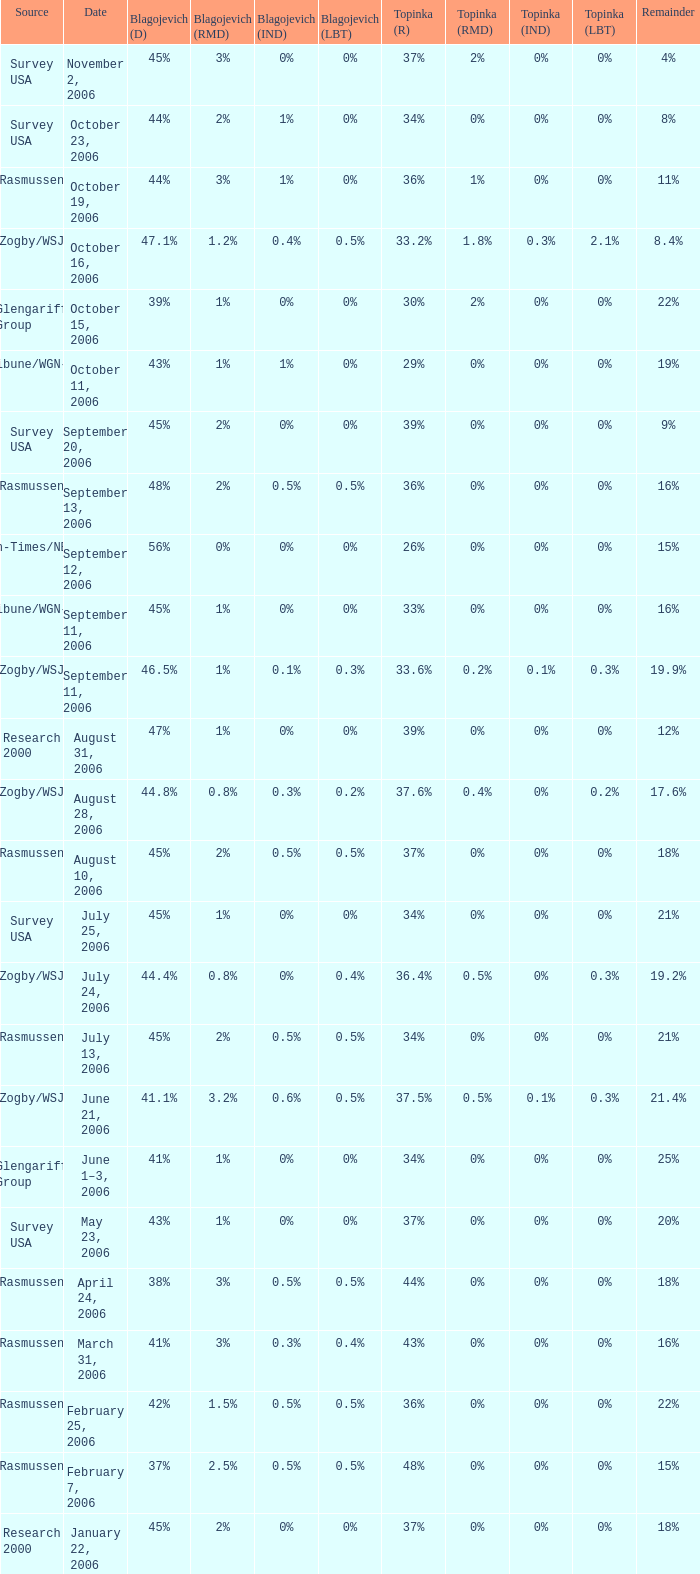Which Source has a Remainder of 15%, and a Topinka of 26%? Sun-Times/NBC5. 